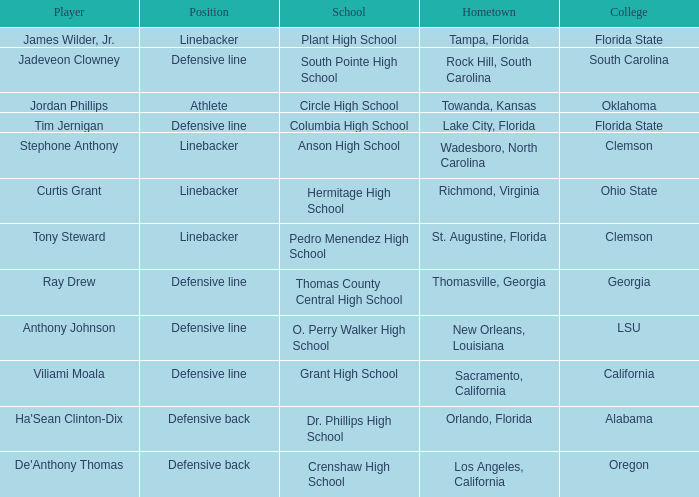What college has a position of defensive line and Grant high school? California. 